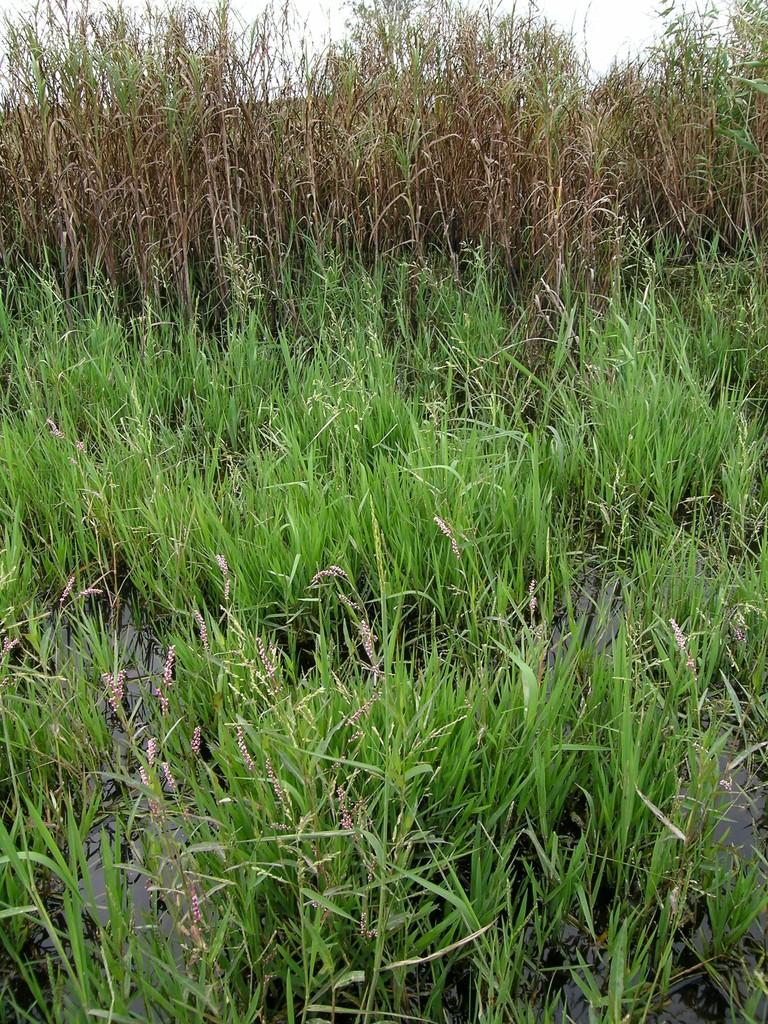What type of vegetation can be seen in the image? There is grass in the image. What else can be seen in the image besides grass? There is water in the image. What can be seen in the background of the image? There are plants and the sky visible in the background of the image. What type of fruit can be seen hanging from the wire in the image? There is no wire or fruit present in the image; it features grass, water, plants, and the sky. 